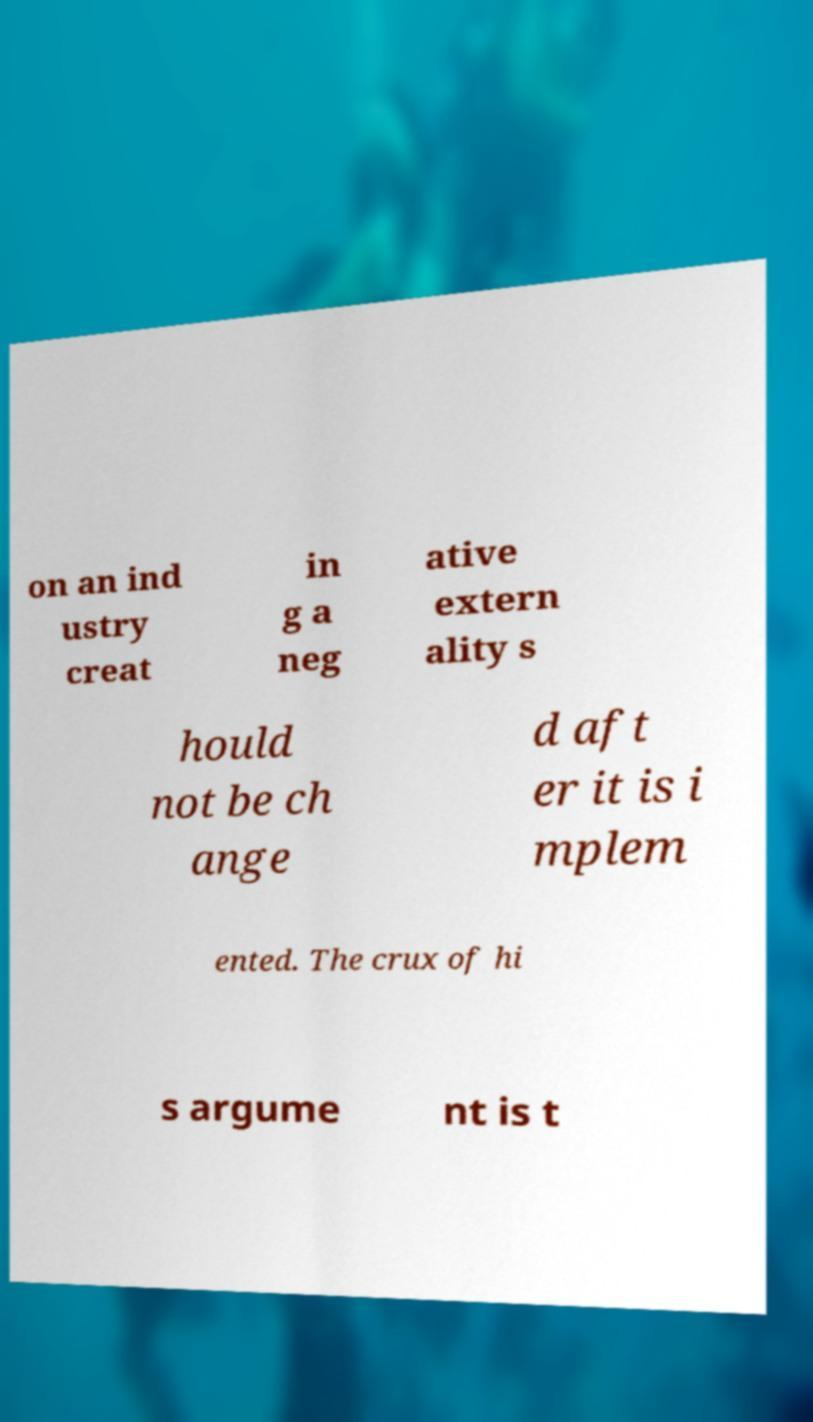I need the written content from this picture converted into text. Can you do that? on an ind ustry creat in g a neg ative extern ality s hould not be ch ange d aft er it is i mplem ented. The crux of hi s argume nt is t 